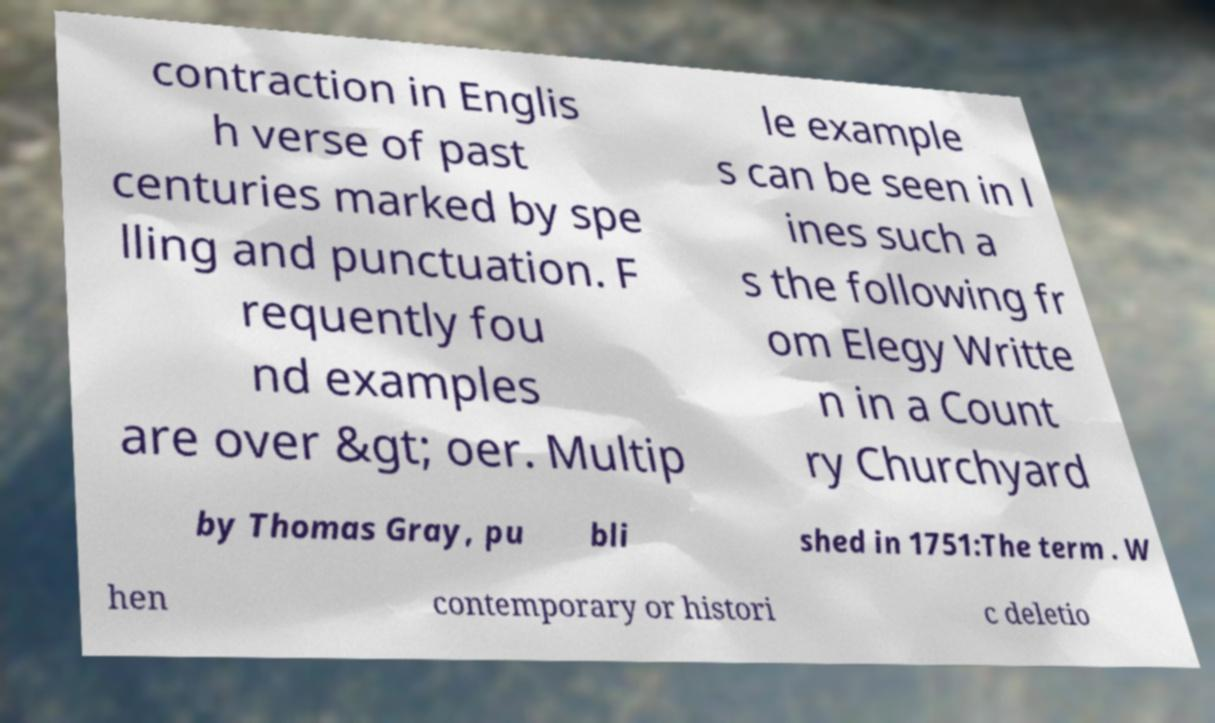Please identify and transcribe the text found in this image. contraction in Englis h verse of past centuries marked by spe lling and punctuation. F requently fou nd examples are over &gt; oer. Multip le example s can be seen in l ines such a s the following fr om Elegy Writte n in a Count ry Churchyard by Thomas Gray, pu bli shed in 1751:The term . W hen contemporary or histori c deletio 